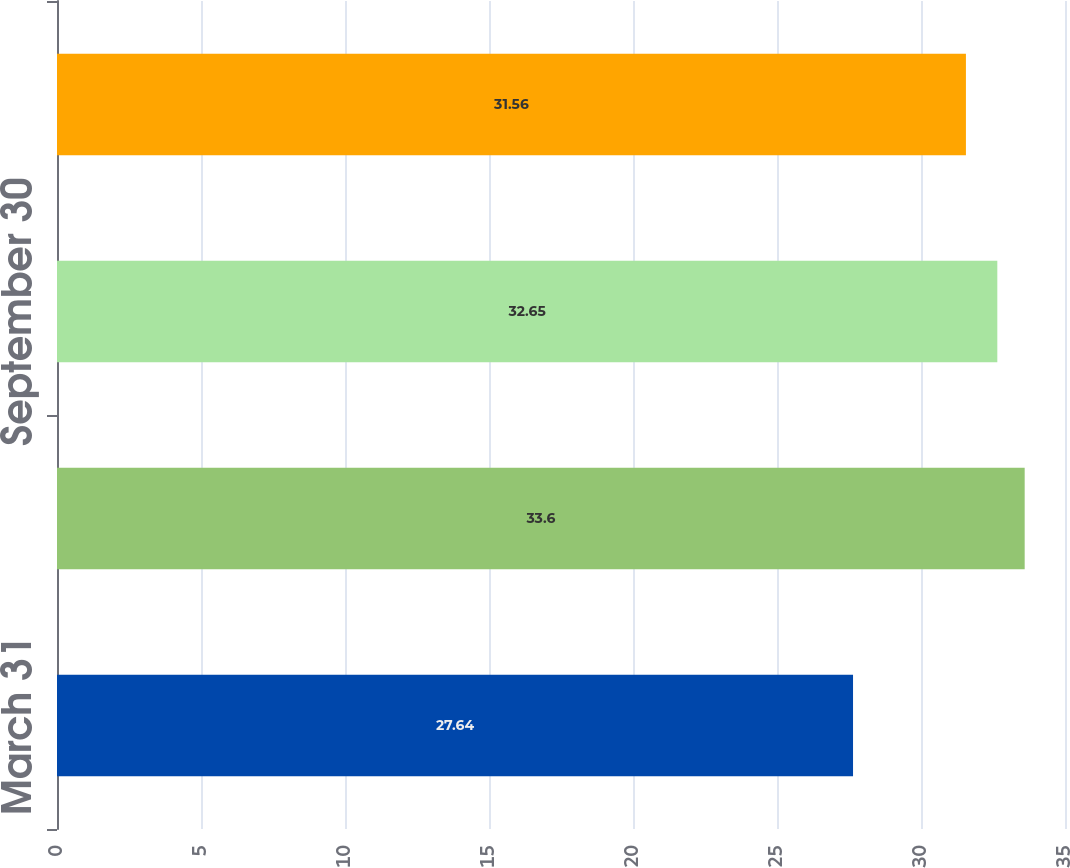<chart> <loc_0><loc_0><loc_500><loc_500><bar_chart><fcel>March 31<fcel>June 30<fcel>September 30<fcel>December 31<nl><fcel>27.64<fcel>33.6<fcel>32.65<fcel>31.56<nl></chart> 